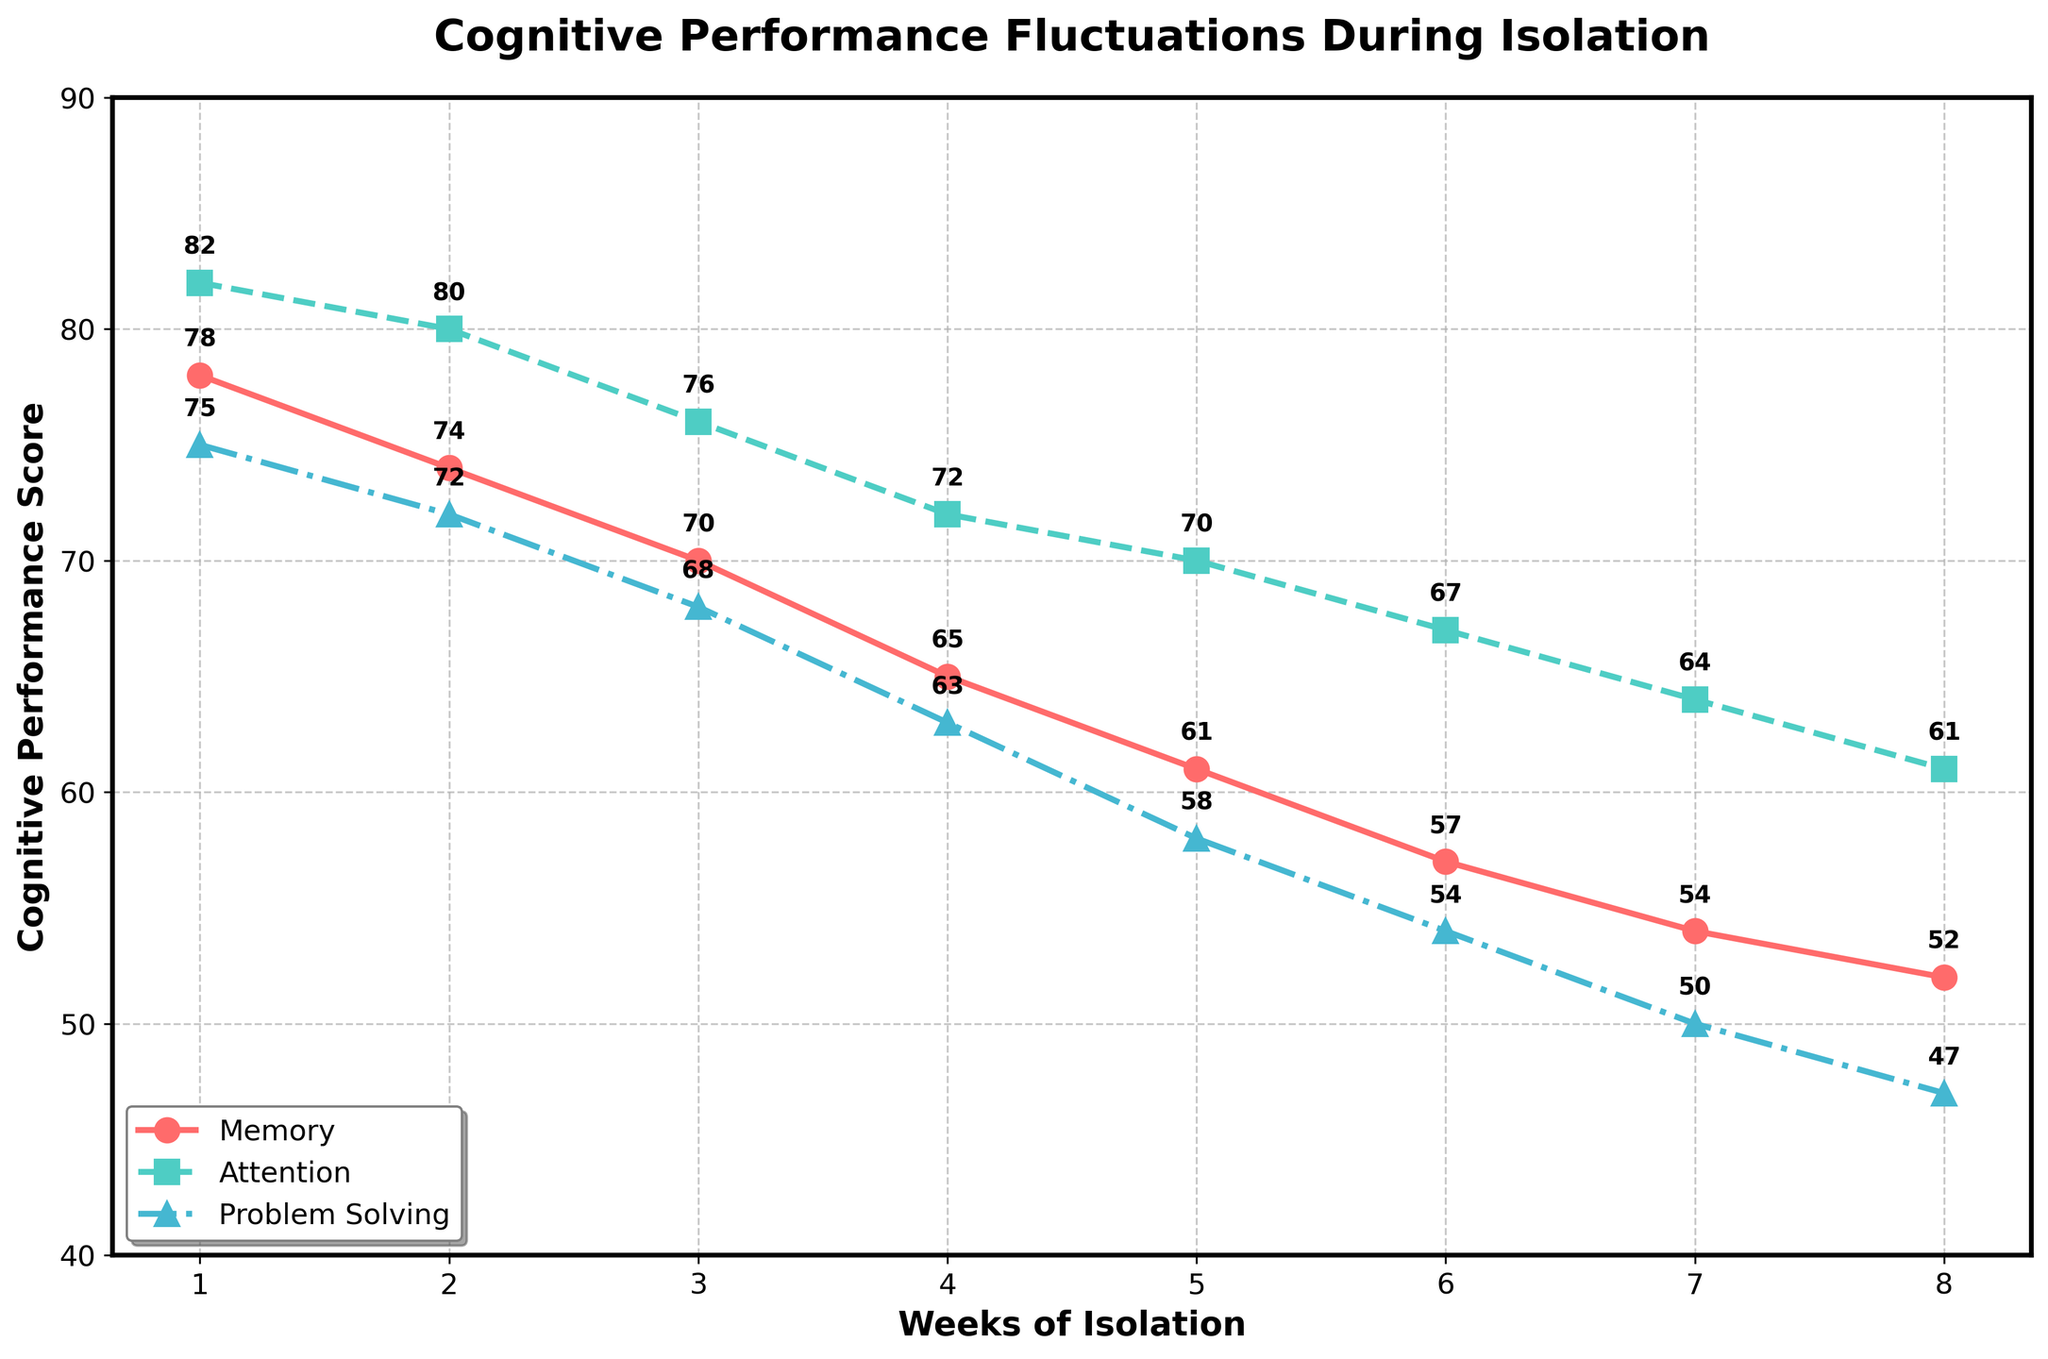What is the title of the plot? The title can be found at the top center of the plot. It is usually in a larger and bolder font. The title gives an overview of what the plot represents.
Answer: Cognitive Performance Fluctuations During Isolation What does the y-axis represent? The label for the y-axis indicates what the measurements in the plot represent. It is normally found vertically along the left side of the plot.
Answer: Cognitive Performance Score What trend do you observe in attention scores over the weeks? By looking at the line representing attention, observe the general direction it moves from Week 1 to Week 8.
Answer: The attention scores continuously decrease over the weeks Which cognitive ability starts with the highest score in Week 1, and what is that score? Examine the data points for Week 1 across Memory, Attention, and Problem Solving. Identify which one is the highest.
Answer: Attention, 82 How much does the memory score decrease from Week 1 to Week 8? Subtract the memory score at Week 8 from the memory score at Week 1. This gives the amount by which it has decreased.
Answer: 26 (78 - 52) Which week shows the sharpest decline in problem-solving ability? Look at the differences in the problem-solving line between each consecutive week. Identify where the largest difference occurs.
Answer: Week 4 to Week 5 Compare the memory and problem-solving abilities in Week 6. Which one is higher, and by how much? Find the data points for Week 6 for both memory and problem-solving. Subtract the lower score from the higher one to find the difference.
Answer: Memory is higher by 3 points (57 - 54) What is the average score of attention over the 8 weeks? Add the attention scores for all 8 weeks and divide by 8 to find the average.
Answer: 72.75 ((82 + 80 + 76 + 72 + 70 + 67 + 64 + 61) / 8) What is the overall trend in cognitive performance for all three abilities over the 8 weeks? Observe the general direction of all three lines (Memory, Attention, and Problem Solving) over the specified weeks.
Answer: All cognitive abilities show a decline over the 8 weeks Which cognitive ability shows the smallest decrease over the 8 weeks? Calculate the difference in scores from Week 1 to Week 8 for Memory, Attention, and Problem Solving, and identify the smallest difference.
Answer: Attention (21 points decrease) 